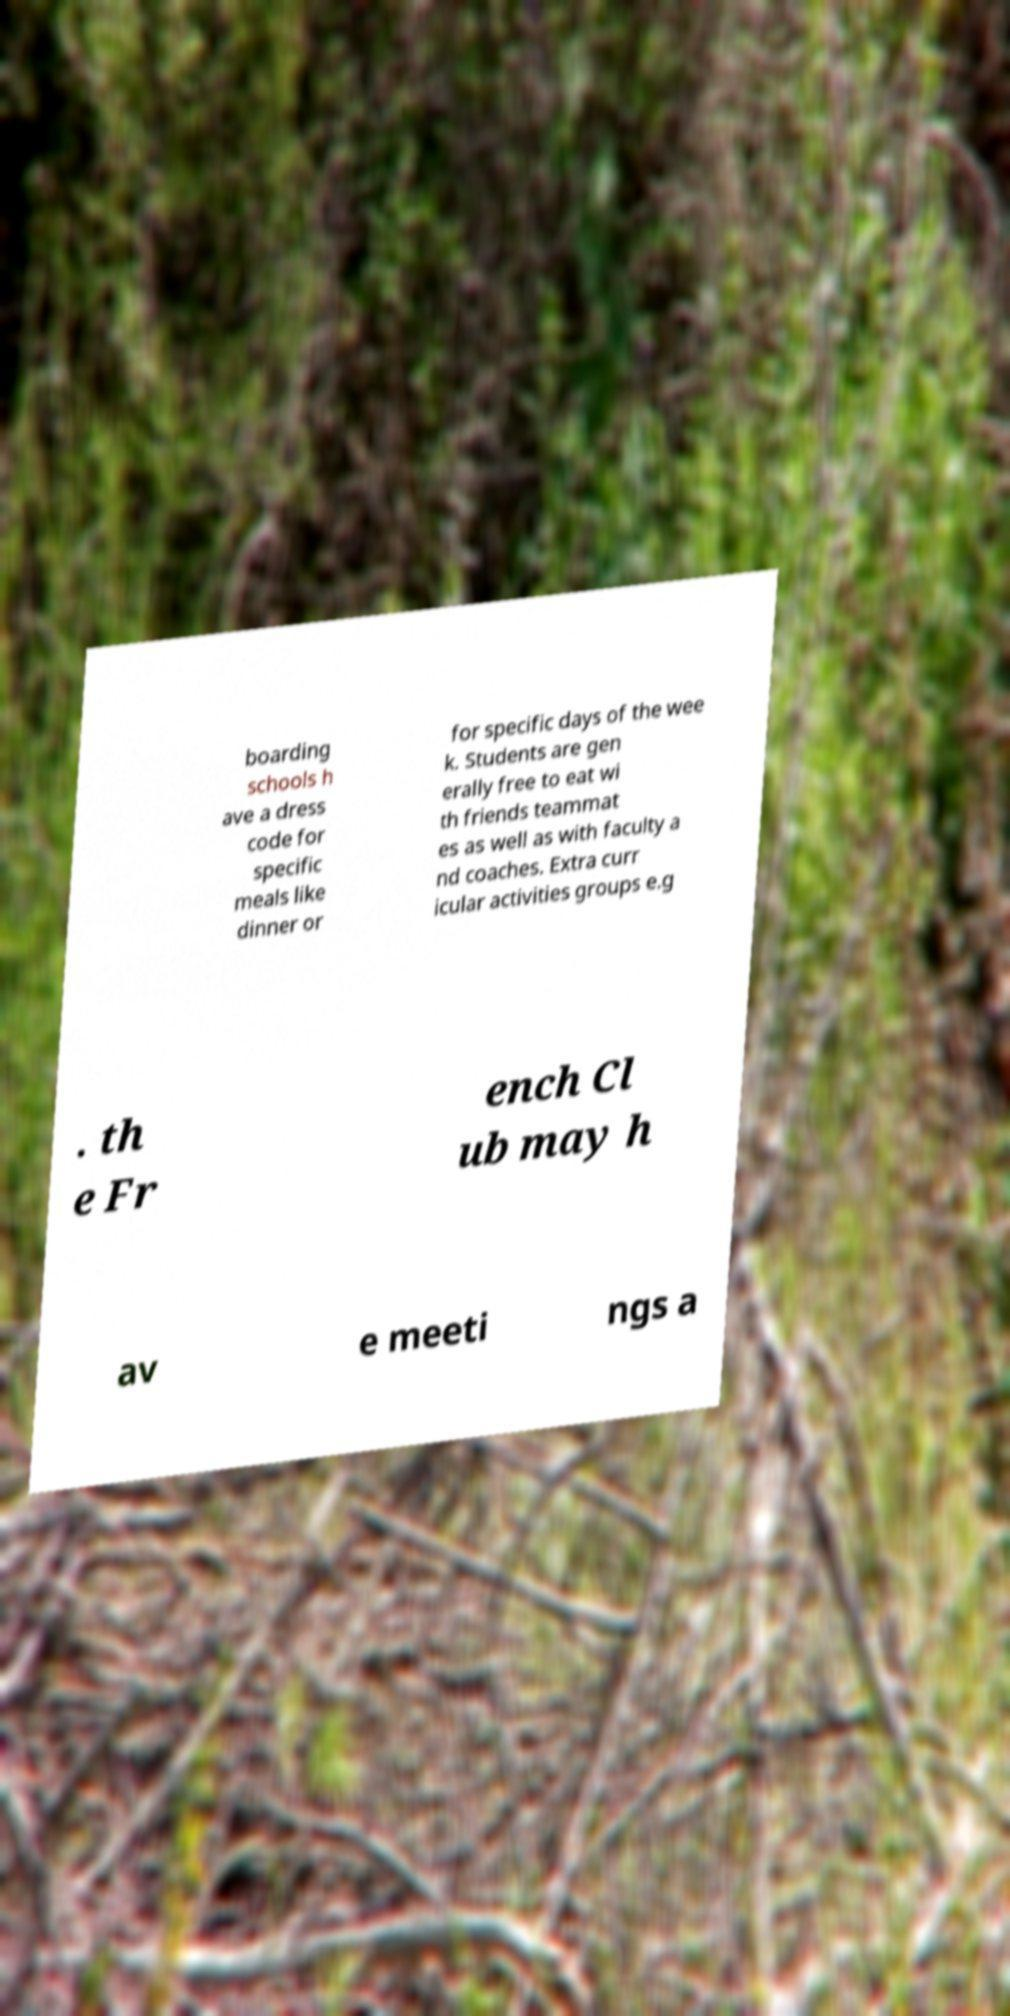Please identify and transcribe the text found in this image. boarding schools h ave a dress code for specific meals like dinner or for specific days of the wee k. Students are gen erally free to eat wi th friends teammat es as well as with faculty a nd coaches. Extra curr icular activities groups e.g . th e Fr ench Cl ub may h av e meeti ngs a 